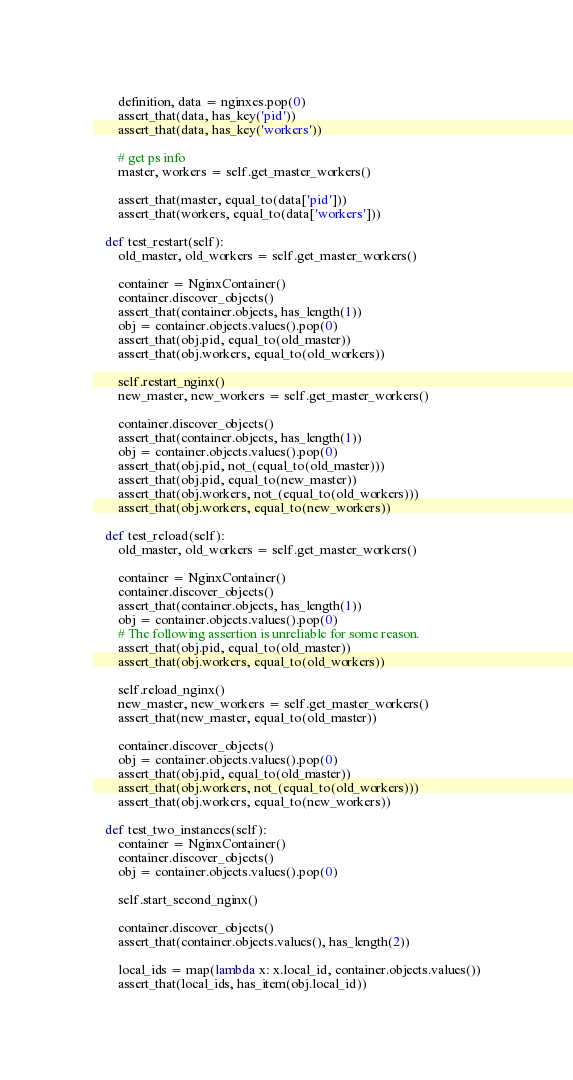<code> <loc_0><loc_0><loc_500><loc_500><_Python_>
        definition, data = nginxes.pop(0)
        assert_that(data, has_key('pid'))
        assert_that(data, has_key('workers'))

        # get ps info
        master, workers = self.get_master_workers()

        assert_that(master, equal_to(data['pid']))
        assert_that(workers, equal_to(data['workers']))

    def test_restart(self):
        old_master, old_workers = self.get_master_workers()

        container = NginxContainer()
        container.discover_objects()
        assert_that(container.objects, has_length(1))
        obj = container.objects.values().pop(0)
        assert_that(obj.pid, equal_to(old_master))
        assert_that(obj.workers, equal_to(old_workers))

        self.restart_nginx()
        new_master, new_workers = self.get_master_workers()

        container.discover_objects()
        assert_that(container.objects, has_length(1))
        obj = container.objects.values().pop(0)
        assert_that(obj.pid, not_(equal_to(old_master)))
        assert_that(obj.pid, equal_to(new_master))
        assert_that(obj.workers, not_(equal_to(old_workers)))
        assert_that(obj.workers, equal_to(new_workers))

    def test_reload(self):
        old_master, old_workers = self.get_master_workers()

        container = NginxContainer()
        container.discover_objects()
        assert_that(container.objects, has_length(1))
        obj = container.objects.values().pop(0)
        # The following assertion is unreliable for some reason.
        assert_that(obj.pid, equal_to(old_master))
        assert_that(obj.workers, equal_to(old_workers))

        self.reload_nginx()
        new_master, new_workers = self.get_master_workers()
        assert_that(new_master, equal_to(old_master))

        container.discover_objects()
        obj = container.objects.values().pop(0)
        assert_that(obj.pid, equal_to(old_master))
        assert_that(obj.workers, not_(equal_to(old_workers)))
        assert_that(obj.workers, equal_to(new_workers))

    def test_two_instances(self):
        container = NginxContainer()
        container.discover_objects()
        obj = container.objects.values().pop(0)

        self.start_second_nginx()

        container.discover_objects()
        assert_that(container.objects.values(), has_length(2))

        local_ids = map(lambda x: x.local_id, container.objects.values())
        assert_that(local_ids, has_item(obj.local_id))

</code> 